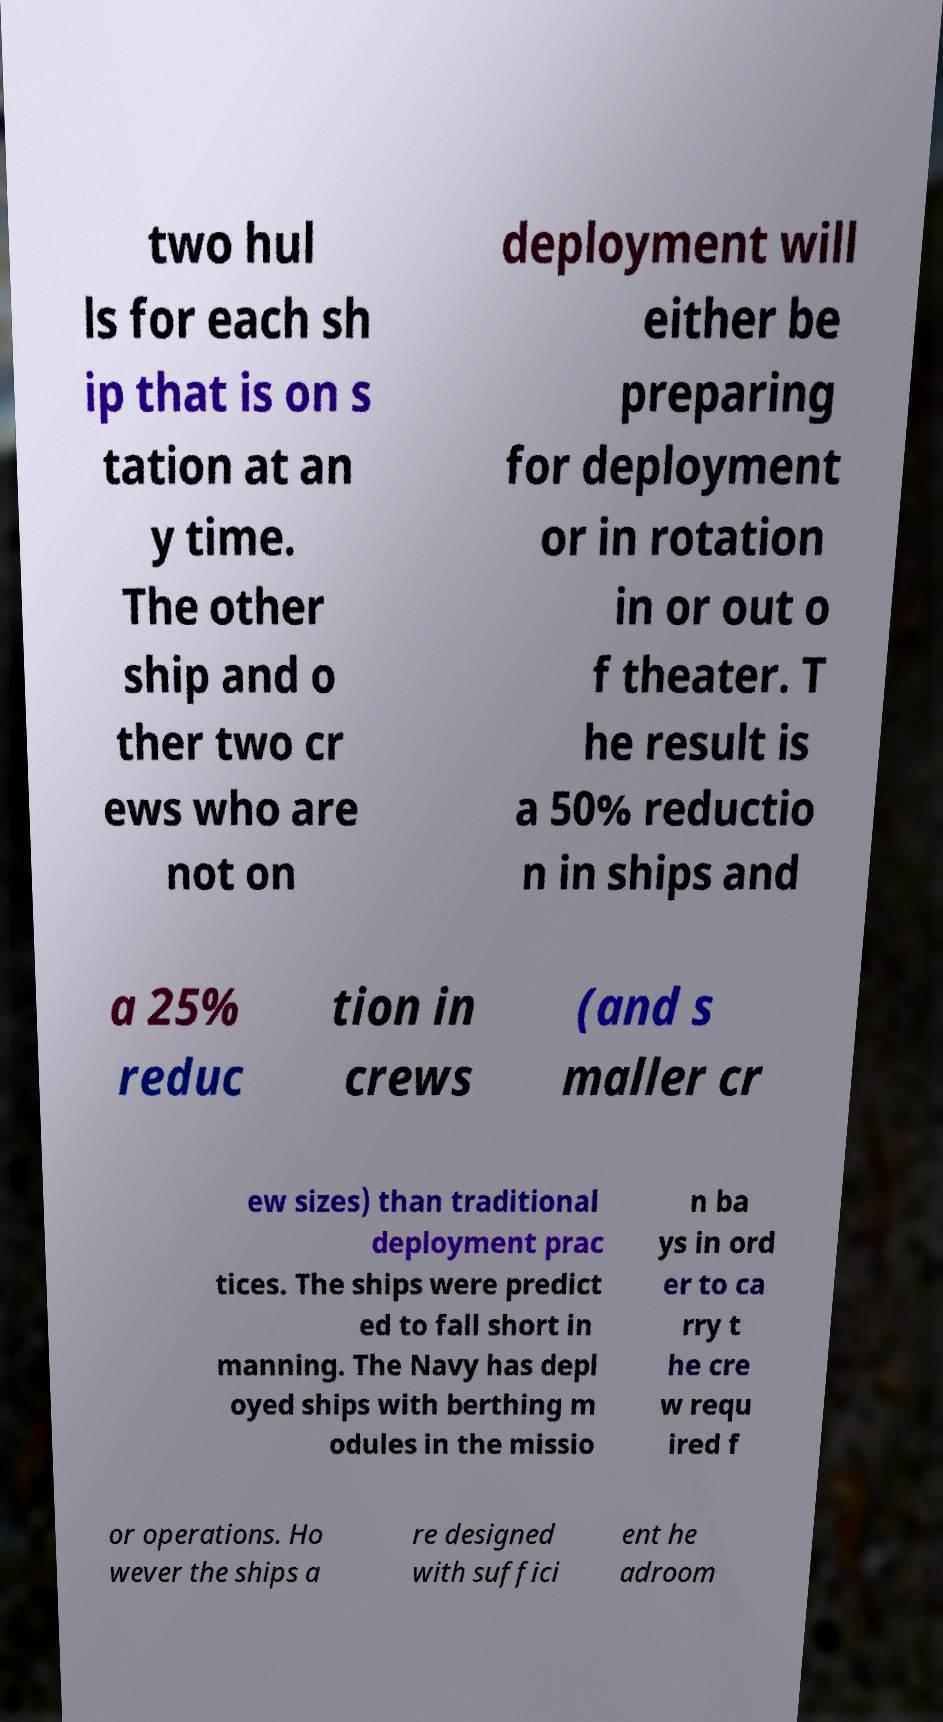Please identify and transcribe the text found in this image. two hul ls for each sh ip that is on s tation at an y time. The other ship and o ther two cr ews who are not on deployment will either be preparing for deployment or in rotation in or out o f theater. T he result is a 50% reductio n in ships and a 25% reduc tion in crews (and s maller cr ew sizes) than traditional deployment prac tices. The ships were predict ed to fall short in manning. The Navy has depl oyed ships with berthing m odules in the missio n ba ys in ord er to ca rry t he cre w requ ired f or operations. Ho wever the ships a re designed with suffici ent he adroom 